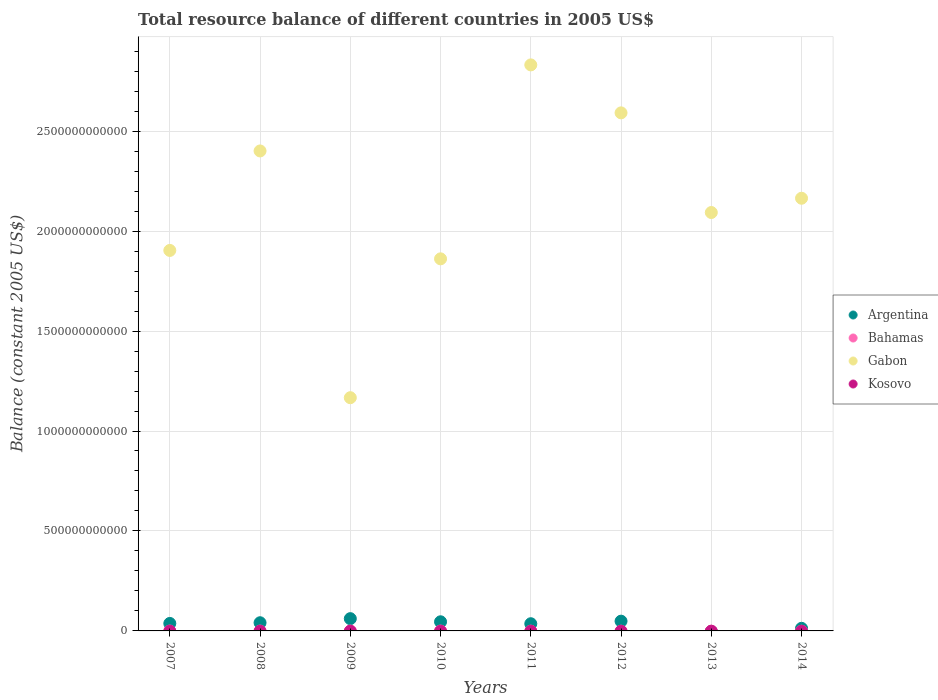How many different coloured dotlines are there?
Ensure brevity in your answer.  2. Is the number of dotlines equal to the number of legend labels?
Your answer should be very brief. No. What is the total resource balance in Gabon in 2011?
Ensure brevity in your answer.  2.83e+12. Across all years, what is the maximum total resource balance in Gabon?
Provide a succinct answer. 2.83e+12. Across all years, what is the minimum total resource balance in Gabon?
Make the answer very short. 1.17e+12. In which year was the total resource balance in Gabon maximum?
Your answer should be compact. 2011. What is the difference between the total resource balance in Gabon in 2008 and that in 2012?
Your response must be concise. -1.91e+11. What is the difference between the total resource balance in Gabon in 2013 and the total resource balance in Argentina in 2009?
Give a very brief answer. 2.03e+12. What is the average total resource balance in Argentina per year?
Keep it short and to the point. 3.54e+1. What is the ratio of the total resource balance in Argentina in 2008 to that in 2014?
Make the answer very short. 3.15. What is the difference between the highest and the second highest total resource balance in Argentina?
Provide a short and direct response. 1.26e+1. What is the difference between the highest and the lowest total resource balance in Gabon?
Offer a terse response. 1.66e+12. Is the sum of the total resource balance in Gabon in 2008 and 2014 greater than the maximum total resource balance in Bahamas across all years?
Give a very brief answer. Yes. Is it the case that in every year, the sum of the total resource balance in Kosovo and total resource balance in Argentina  is greater than the sum of total resource balance in Bahamas and total resource balance in Gabon?
Offer a very short reply. No. Does the total resource balance in Kosovo monotonically increase over the years?
Ensure brevity in your answer.  No. Is the total resource balance in Bahamas strictly less than the total resource balance in Kosovo over the years?
Make the answer very short. No. How many dotlines are there?
Keep it short and to the point. 2. How many years are there in the graph?
Give a very brief answer. 8. What is the difference between two consecutive major ticks on the Y-axis?
Your answer should be very brief. 5.00e+11. Are the values on the major ticks of Y-axis written in scientific E-notation?
Ensure brevity in your answer.  No. Does the graph contain any zero values?
Provide a short and direct response. Yes. How many legend labels are there?
Provide a short and direct response. 4. What is the title of the graph?
Ensure brevity in your answer.  Total resource balance of different countries in 2005 US$. Does "Senegal" appear as one of the legend labels in the graph?
Give a very brief answer. No. What is the label or title of the Y-axis?
Provide a succinct answer. Balance (constant 2005 US$). What is the Balance (constant 2005 US$) in Argentina in 2007?
Give a very brief answer. 3.74e+1. What is the Balance (constant 2005 US$) of Gabon in 2007?
Give a very brief answer. 1.90e+12. What is the Balance (constant 2005 US$) of Kosovo in 2007?
Your response must be concise. 0. What is the Balance (constant 2005 US$) of Argentina in 2008?
Offer a very short reply. 4.09e+1. What is the Balance (constant 2005 US$) of Bahamas in 2008?
Give a very brief answer. 0. What is the Balance (constant 2005 US$) in Gabon in 2008?
Provide a short and direct response. 2.40e+12. What is the Balance (constant 2005 US$) in Argentina in 2009?
Keep it short and to the point. 6.14e+1. What is the Balance (constant 2005 US$) of Bahamas in 2009?
Offer a terse response. 0. What is the Balance (constant 2005 US$) in Gabon in 2009?
Give a very brief answer. 1.17e+12. What is the Balance (constant 2005 US$) of Kosovo in 2009?
Offer a very short reply. 0. What is the Balance (constant 2005 US$) of Argentina in 2010?
Provide a short and direct response. 4.57e+1. What is the Balance (constant 2005 US$) of Gabon in 2010?
Keep it short and to the point. 1.86e+12. What is the Balance (constant 2005 US$) of Argentina in 2011?
Offer a very short reply. 3.60e+1. What is the Balance (constant 2005 US$) of Gabon in 2011?
Offer a very short reply. 2.83e+12. What is the Balance (constant 2005 US$) in Kosovo in 2011?
Offer a terse response. 0. What is the Balance (constant 2005 US$) of Argentina in 2012?
Provide a succinct answer. 4.88e+1. What is the Balance (constant 2005 US$) of Bahamas in 2012?
Make the answer very short. 0. What is the Balance (constant 2005 US$) of Gabon in 2012?
Your answer should be compact. 2.59e+12. What is the Balance (constant 2005 US$) in Argentina in 2013?
Keep it short and to the point. 0. What is the Balance (constant 2005 US$) of Bahamas in 2013?
Your response must be concise. 0. What is the Balance (constant 2005 US$) in Gabon in 2013?
Make the answer very short. 2.09e+12. What is the Balance (constant 2005 US$) in Kosovo in 2013?
Give a very brief answer. 0. What is the Balance (constant 2005 US$) in Argentina in 2014?
Offer a terse response. 1.30e+1. What is the Balance (constant 2005 US$) in Bahamas in 2014?
Provide a short and direct response. 0. What is the Balance (constant 2005 US$) of Gabon in 2014?
Your answer should be compact. 2.16e+12. Across all years, what is the maximum Balance (constant 2005 US$) of Argentina?
Your response must be concise. 6.14e+1. Across all years, what is the maximum Balance (constant 2005 US$) of Gabon?
Keep it short and to the point. 2.83e+12. Across all years, what is the minimum Balance (constant 2005 US$) of Gabon?
Provide a short and direct response. 1.17e+12. What is the total Balance (constant 2005 US$) in Argentina in the graph?
Give a very brief answer. 2.83e+11. What is the total Balance (constant 2005 US$) in Gabon in the graph?
Make the answer very short. 1.70e+13. What is the total Balance (constant 2005 US$) of Kosovo in the graph?
Keep it short and to the point. 0. What is the difference between the Balance (constant 2005 US$) of Argentina in 2007 and that in 2008?
Give a very brief answer. -3.49e+09. What is the difference between the Balance (constant 2005 US$) of Gabon in 2007 and that in 2008?
Provide a short and direct response. -4.98e+11. What is the difference between the Balance (constant 2005 US$) of Argentina in 2007 and that in 2009?
Your response must be concise. -2.39e+1. What is the difference between the Balance (constant 2005 US$) of Gabon in 2007 and that in 2009?
Give a very brief answer. 7.37e+11. What is the difference between the Balance (constant 2005 US$) of Argentina in 2007 and that in 2010?
Ensure brevity in your answer.  -8.25e+09. What is the difference between the Balance (constant 2005 US$) in Gabon in 2007 and that in 2010?
Provide a succinct answer. 4.21e+1. What is the difference between the Balance (constant 2005 US$) of Argentina in 2007 and that in 2011?
Your response must be concise. 1.47e+09. What is the difference between the Balance (constant 2005 US$) of Gabon in 2007 and that in 2011?
Keep it short and to the point. -9.28e+11. What is the difference between the Balance (constant 2005 US$) in Argentina in 2007 and that in 2012?
Your answer should be compact. -1.14e+1. What is the difference between the Balance (constant 2005 US$) in Gabon in 2007 and that in 2012?
Your response must be concise. -6.88e+11. What is the difference between the Balance (constant 2005 US$) in Gabon in 2007 and that in 2013?
Offer a very short reply. -1.90e+11. What is the difference between the Balance (constant 2005 US$) of Argentina in 2007 and that in 2014?
Your answer should be compact. 2.44e+1. What is the difference between the Balance (constant 2005 US$) of Gabon in 2007 and that in 2014?
Offer a terse response. -2.61e+11. What is the difference between the Balance (constant 2005 US$) of Argentina in 2008 and that in 2009?
Ensure brevity in your answer.  -2.04e+1. What is the difference between the Balance (constant 2005 US$) in Gabon in 2008 and that in 2009?
Offer a very short reply. 1.23e+12. What is the difference between the Balance (constant 2005 US$) of Argentina in 2008 and that in 2010?
Offer a terse response. -4.76e+09. What is the difference between the Balance (constant 2005 US$) in Gabon in 2008 and that in 2010?
Ensure brevity in your answer.  5.40e+11. What is the difference between the Balance (constant 2005 US$) of Argentina in 2008 and that in 2011?
Provide a short and direct response. 4.96e+09. What is the difference between the Balance (constant 2005 US$) in Gabon in 2008 and that in 2011?
Your answer should be compact. -4.30e+11. What is the difference between the Balance (constant 2005 US$) in Argentina in 2008 and that in 2012?
Provide a short and direct response. -7.87e+09. What is the difference between the Balance (constant 2005 US$) of Gabon in 2008 and that in 2012?
Your response must be concise. -1.91e+11. What is the difference between the Balance (constant 2005 US$) of Gabon in 2008 and that in 2013?
Keep it short and to the point. 3.08e+11. What is the difference between the Balance (constant 2005 US$) in Argentina in 2008 and that in 2014?
Keep it short and to the point. 2.79e+1. What is the difference between the Balance (constant 2005 US$) in Gabon in 2008 and that in 2014?
Keep it short and to the point. 2.37e+11. What is the difference between the Balance (constant 2005 US$) in Argentina in 2009 and that in 2010?
Your response must be concise. 1.57e+1. What is the difference between the Balance (constant 2005 US$) of Gabon in 2009 and that in 2010?
Your answer should be compact. -6.95e+11. What is the difference between the Balance (constant 2005 US$) in Argentina in 2009 and that in 2011?
Your answer should be very brief. 2.54e+1. What is the difference between the Balance (constant 2005 US$) of Gabon in 2009 and that in 2011?
Your answer should be very brief. -1.66e+12. What is the difference between the Balance (constant 2005 US$) of Argentina in 2009 and that in 2012?
Your response must be concise. 1.26e+1. What is the difference between the Balance (constant 2005 US$) in Gabon in 2009 and that in 2012?
Your response must be concise. -1.42e+12. What is the difference between the Balance (constant 2005 US$) in Gabon in 2009 and that in 2013?
Provide a short and direct response. -9.26e+11. What is the difference between the Balance (constant 2005 US$) in Argentina in 2009 and that in 2014?
Make the answer very short. 4.84e+1. What is the difference between the Balance (constant 2005 US$) in Gabon in 2009 and that in 2014?
Provide a short and direct response. -9.98e+11. What is the difference between the Balance (constant 2005 US$) in Argentina in 2010 and that in 2011?
Ensure brevity in your answer.  9.71e+09. What is the difference between the Balance (constant 2005 US$) in Gabon in 2010 and that in 2011?
Your response must be concise. -9.70e+11. What is the difference between the Balance (constant 2005 US$) in Argentina in 2010 and that in 2012?
Your answer should be very brief. -3.11e+09. What is the difference between the Balance (constant 2005 US$) of Gabon in 2010 and that in 2012?
Your response must be concise. -7.30e+11. What is the difference between the Balance (constant 2005 US$) of Gabon in 2010 and that in 2013?
Keep it short and to the point. -2.32e+11. What is the difference between the Balance (constant 2005 US$) of Argentina in 2010 and that in 2014?
Provide a succinct answer. 3.27e+1. What is the difference between the Balance (constant 2005 US$) of Gabon in 2010 and that in 2014?
Provide a short and direct response. -3.03e+11. What is the difference between the Balance (constant 2005 US$) of Argentina in 2011 and that in 2012?
Provide a succinct answer. -1.28e+1. What is the difference between the Balance (constant 2005 US$) in Gabon in 2011 and that in 2012?
Your answer should be very brief. 2.40e+11. What is the difference between the Balance (constant 2005 US$) in Gabon in 2011 and that in 2013?
Your response must be concise. 7.38e+11. What is the difference between the Balance (constant 2005 US$) of Argentina in 2011 and that in 2014?
Make the answer very short. 2.30e+1. What is the difference between the Balance (constant 2005 US$) of Gabon in 2011 and that in 2014?
Offer a terse response. 6.67e+11. What is the difference between the Balance (constant 2005 US$) of Gabon in 2012 and that in 2013?
Offer a terse response. 4.99e+11. What is the difference between the Balance (constant 2005 US$) of Argentina in 2012 and that in 2014?
Provide a short and direct response. 3.58e+1. What is the difference between the Balance (constant 2005 US$) of Gabon in 2012 and that in 2014?
Your response must be concise. 4.27e+11. What is the difference between the Balance (constant 2005 US$) of Gabon in 2013 and that in 2014?
Your response must be concise. -7.14e+1. What is the difference between the Balance (constant 2005 US$) of Argentina in 2007 and the Balance (constant 2005 US$) of Gabon in 2008?
Make the answer very short. -2.36e+12. What is the difference between the Balance (constant 2005 US$) in Argentina in 2007 and the Balance (constant 2005 US$) in Gabon in 2009?
Offer a terse response. -1.13e+12. What is the difference between the Balance (constant 2005 US$) of Argentina in 2007 and the Balance (constant 2005 US$) of Gabon in 2010?
Provide a succinct answer. -1.82e+12. What is the difference between the Balance (constant 2005 US$) of Argentina in 2007 and the Balance (constant 2005 US$) of Gabon in 2011?
Offer a very short reply. -2.79e+12. What is the difference between the Balance (constant 2005 US$) of Argentina in 2007 and the Balance (constant 2005 US$) of Gabon in 2012?
Offer a very short reply. -2.55e+12. What is the difference between the Balance (constant 2005 US$) of Argentina in 2007 and the Balance (constant 2005 US$) of Gabon in 2013?
Offer a very short reply. -2.06e+12. What is the difference between the Balance (constant 2005 US$) in Argentina in 2007 and the Balance (constant 2005 US$) in Gabon in 2014?
Offer a terse response. -2.13e+12. What is the difference between the Balance (constant 2005 US$) in Argentina in 2008 and the Balance (constant 2005 US$) in Gabon in 2009?
Provide a short and direct response. -1.13e+12. What is the difference between the Balance (constant 2005 US$) in Argentina in 2008 and the Balance (constant 2005 US$) in Gabon in 2010?
Your response must be concise. -1.82e+12. What is the difference between the Balance (constant 2005 US$) of Argentina in 2008 and the Balance (constant 2005 US$) of Gabon in 2011?
Provide a short and direct response. -2.79e+12. What is the difference between the Balance (constant 2005 US$) of Argentina in 2008 and the Balance (constant 2005 US$) of Gabon in 2012?
Provide a short and direct response. -2.55e+12. What is the difference between the Balance (constant 2005 US$) in Argentina in 2008 and the Balance (constant 2005 US$) in Gabon in 2013?
Keep it short and to the point. -2.05e+12. What is the difference between the Balance (constant 2005 US$) of Argentina in 2008 and the Balance (constant 2005 US$) of Gabon in 2014?
Your answer should be compact. -2.12e+12. What is the difference between the Balance (constant 2005 US$) in Argentina in 2009 and the Balance (constant 2005 US$) in Gabon in 2010?
Offer a very short reply. -1.80e+12. What is the difference between the Balance (constant 2005 US$) of Argentina in 2009 and the Balance (constant 2005 US$) of Gabon in 2011?
Offer a terse response. -2.77e+12. What is the difference between the Balance (constant 2005 US$) in Argentina in 2009 and the Balance (constant 2005 US$) in Gabon in 2012?
Your answer should be compact. -2.53e+12. What is the difference between the Balance (constant 2005 US$) of Argentina in 2009 and the Balance (constant 2005 US$) of Gabon in 2013?
Provide a succinct answer. -2.03e+12. What is the difference between the Balance (constant 2005 US$) of Argentina in 2009 and the Balance (constant 2005 US$) of Gabon in 2014?
Ensure brevity in your answer.  -2.10e+12. What is the difference between the Balance (constant 2005 US$) in Argentina in 2010 and the Balance (constant 2005 US$) in Gabon in 2011?
Keep it short and to the point. -2.79e+12. What is the difference between the Balance (constant 2005 US$) of Argentina in 2010 and the Balance (constant 2005 US$) of Gabon in 2012?
Your response must be concise. -2.55e+12. What is the difference between the Balance (constant 2005 US$) of Argentina in 2010 and the Balance (constant 2005 US$) of Gabon in 2013?
Provide a succinct answer. -2.05e+12. What is the difference between the Balance (constant 2005 US$) in Argentina in 2010 and the Balance (constant 2005 US$) in Gabon in 2014?
Keep it short and to the point. -2.12e+12. What is the difference between the Balance (constant 2005 US$) in Argentina in 2011 and the Balance (constant 2005 US$) in Gabon in 2012?
Give a very brief answer. -2.56e+12. What is the difference between the Balance (constant 2005 US$) in Argentina in 2011 and the Balance (constant 2005 US$) in Gabon in 2013?
Provide a short and direct response. -2.06e+12. What is the difference between the Balance (constant 2005 US$) of Argentina in 2011 and the Balance (constant 2005 US$) of Gabon in 2014?
Make the answer very short. -2.13e+12. What is the difference between the Balance (constant 2005 US$) in Argentina in 2012 and the Balance (constant 2005 US$) in Gabon in 2013?
Provide a short and direct response. -2.04e+12. What is the difference between the Balance (constant 2005 US$) in Argentina in 2012 and the Balance (constant 2005 US$) in Gabon in 2014?
Provide a succinct answer. -2.12e+12. What is the average Balance (constant 2005 US$) in Argentina per year?
Give a very brief answer. 3.54e+1. What is the average Balance (constant 2005 US$) in Gabon per year?
Ensure brevity in your answer.  2.13e+12. What is the average Balance (constant 2005 US$) in Kosovo per year?
Your response must be concise. 0. In the year 2007, what is the difference between the Balance (constant 2005 US$) in Argentina and Balance (constant 2005 US$) in Gabon?
Offer a terse response. -1.87e+12. In the year 2008, what is the difference between the Balance (constant 2005 US$) of Argentina and Balance (constant 2005 US$) of Gabon?
Provide a short and direct response. -2.36e+12. In the year 2009, what is the difference between the Balance (constant 2005 US$) of Argentina and Balance (constant 2005 US$) of Gabon?
Your answer should be very brief. -1.11e+12. In the year 2010, what is the difference between the Balance (constant 2005 US$) of Argentina and Balance (constant 2005 US$) of Gabon?
Your answer should be very brief. -1.82e+12. In the year 2011, what is the difference between the Balance (constant 2005 US$) in Argentina and Balance (constant 2005 US$) in Gabon?
Give a very brief answer. -2.80e+12. In the year 2012, what is the difference between the Balance (constant 2005 US$) of Argentina and Balance (constant 2005 US$) of Gabon?
Provide a short and direct response. -2.54e+12. In the year 2014, what is the difference between the Balance (constant 2005 US$) of Argentina and Balance (constant 2005 US$) of Gabon?
Ensure brevity in your answer.  -2.15e+12. What is the ratio of the Balance (constant 2005 US$) in Argentina in 2007 to that in 2008?
Your response must be concise. 0.91. What is the ratio of the Balance (constant 2005 US$) of Gabon in 2007 to that in 2008?
Your answer should be very brief. 0.79. What is the ratio of the Balance (constant 2005 US$) of Argentina in 2007 to that in 2009?
Ensure brevity in your answer.  0.61. What is the ratio of the Balance (constant 2005 US$) of Gabon in 2007 to that in 2009?
Make the answer very short. 1.63. What is the ratio of the Balance (constant 2005 US$) in Argentina in 2007 to that in 2010?
Your response must be concise. 0.82. What is the ratio of the Balance (constant 2005 US$) in Gabon in 2007 to that in 2010?
Offer a very short reply. 1.02. What is the ratio of the Balance (constant 2005 US$) in Argentina in 2007 to that in 2011?
Offer a very short reply. 1.04. What is the ratio of the Balance (constant 2005 US$) of Gabon in 2007 to that in 2011?
Your answer should be compact. 0.67. What is the ratio of the Balance (constant 2005 US$) in Argentina in 2007 to that in 2012?
Provide a short and direct response. 0.77. What is the ratio of the Balance (constant 2005 US$) of Gabon in 2007 to that in 2012?
Your answer should be very brief. 0.73. What is the ratio of the Balance (constant 2005 US$) of Gabon in 2007 to that in 2013?
Provide a succinct answer. 0.91. What is the ratio of the Balance (constant 2005 US$) in Argentina in 2007 to that in 2014?
Your response must be concise. 2.88. What is the ratio of the Balance (constant 2005 US$) in Gabon in 2007 to that in 2014?
Give a very brief answer. 0.88. What is the ratio of the Balance (constant 2005 US$) of Argentina in 2008 to that in 2009?
Make the answer very short. 0.67. What is the ratio of the Balance (constant 2005 US$) of Gabon in 2008 to that in 2009?
Your answer should be very brief. 2.06. What is the ratio of the Balance (constant 2005 US$) of Argentina in 2008 to that in 2010?
Your answer should be compact. 0.9. What is the ratio of the Balance (constant 2005 US$) of Gabon in 2008 to that in 2010?
Make the answer very short. 1.29. What is the ratio of the Balance (constant 2005 US$) of Argentina in 2008 to that in 2011?
Make the answer very short. 1.14. What is the ratio of the Balance (constant 2005 US$) of Gabon in 2008 to that in 2011?
Your response must be concise. 0.85. What is the ratio of the Balance (constant 2005 US$) in Argentina in 2008 to that in 2012?
Provide a succinct answer. 0.84. What is the ratio of the Balance (constant 2005 US$) in Gabon in 2008 to that in 2012?
Ensure brevity in your answer.  0.93. What is the ratio of the Balance (constant 2005 US$) in Gabon in 2008 to that in 2013?
Offer a very short reply. 1.15. What is the ratio of the Balance (constant 2005 US$) of Argentina in 2008 to that in 2014?
Provide a short and direct response. 3.15. What is the ratio of the Balance (constant 2005 US$) of Gabon in 2008 to that in 2014?
Offer a very short reply. 1.11. What is the ratio of the Balance (constant 2005 US$) of Argentina in 2009 to that in 2010?
Offer a terse response. 1.34. What is the ratio of the Balance (constant 2005 US$) of Gabon in 2009 to that in 2010?
Keep it short and to the point. 0.63. What is the ratio of the Balance (constant 2005 US$) of Argentina in 2009 to that in 2011?
Provide a succinct answer. 1.71. What is the ratio of the Balance (constant 2005 US$) of Gabon in 2009 to that in 2011?
Offer a very short reply. 0.41. What is the ratio of the Balance (constant 2005 US$) in Argentina in 2009 to that in 2012?
Provide a short and direct response. 1.26. What is the ratio of the Balance (constant 2005 US$) in Gabon in 2009 to that in 2012?
Make the answer very short. 0.45. What is the ratio of the Balance (constant 2005 US$) in Gabon in 2009 to that in 2013?
Provide a succinct answer. 0.56. What is the ratio of the Balance (constant 2005 US$) in Argentina in 2009 to that in 2014?
Your answer should be compact. 4.72. What is the ratio of the Balance (constant 2005 US$) in Gabon in 2009 to that in 2014?
Offer a terse response. 0.54. What is the ratio of the Balance (constant 2005 US$) in Argentina in 2010 to that in 2011?
Offer a terse response. 1.27. What is the ratio of the Balance (constant 2005 US$) of Gabon in 2010 to that in 2011?
Give a very brief answer. 0.66. What is the ratio of the Balance (constant 2005 US$) of Argentina in 2010 to that in 2012?
Provide a short and direct response. 0.94. What is the ratio of the Balance (constant 2005 US$) in Gabon in 2010 to that in 2012?
Offer a very short reply. 0.72. What is the ratio of the Balance (constant 2005 US$) in Gabon in 2010 to that in 2013?
Make the answer very short. 0.89. What is the ratio of the Balance (constant 2005 US$) in Argentina in 2010 to that in 2014?
Your response must be concise. 3.51. What is the ratio of the Balance (constant 2005 US$) in Gabon in 2010 to that in 2014?
Make the answer very short. 0.86. What is the ratio of the Balance (constant 2005 US$) in Argentina in 2011 to that in 2012?
Your response must be concise. 0.74. What is the ratio of the Balance (constant 2005 US$) of Gabon in 2011 to that in 2012?
Your answer should be very brief. 1.09. What is the ratio of the Balance (constant 2005 US$) of Gabon in 2011 to that in 2013?
Make the answer very short. 1.35. What is the ratio of the Balance (constant 2005 US$) of Argentina in 2011 to that in 2014?
Provide a short and direct response. 2.77. What is the ratio of the Balance (constant 2005 US$) of Gabon in 2011 to that in 2014?
Offer a very short reply. 1.31. What is the ratio of the Balance (constant 2005 US$) of Gabon in 2012 to that in 2013?
Provide a succinct answer. 1.24. What is the ratio of the Balance (constant 2005 US$) of Argentina in 2012 to that in 2014?
Your answer should be very brief. 3.75. What is the ratio of the Balance (constant 2005 US$) in Gabon in 2012 to that in 2014?
Your answer should be very brief. 1.2. What is the ratio of the Balance (constant 2005 US$) in Gabon in 2013 to that in 2014?
Keep it short and to the point. 0.97. What is the difference between the highest and the second highest Balance (constant 2005 US$) of Argentina?
Ensure brevity in your answer.  1.26e+1. What is the difference between the highest and the second highest Balance (constant 2005 US$) of Gabon?
Keep it short and to the point. 2.40e+11. What is the difference between the highest and the lowest Balance (constant 2005 US$) in Argentina?
Provide a succinct answer. 6.14e+1. What is the difference between the highest and the lowest Balance (constant 2005 US$) in Gabon?
Provide a short and direct response. 1.66e+12. 